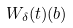Convert formula to latex. <formula><loc_0><loc_0><loc_500><loc_500>W _ { \delta } ( t ) ( { b } )</formula> 